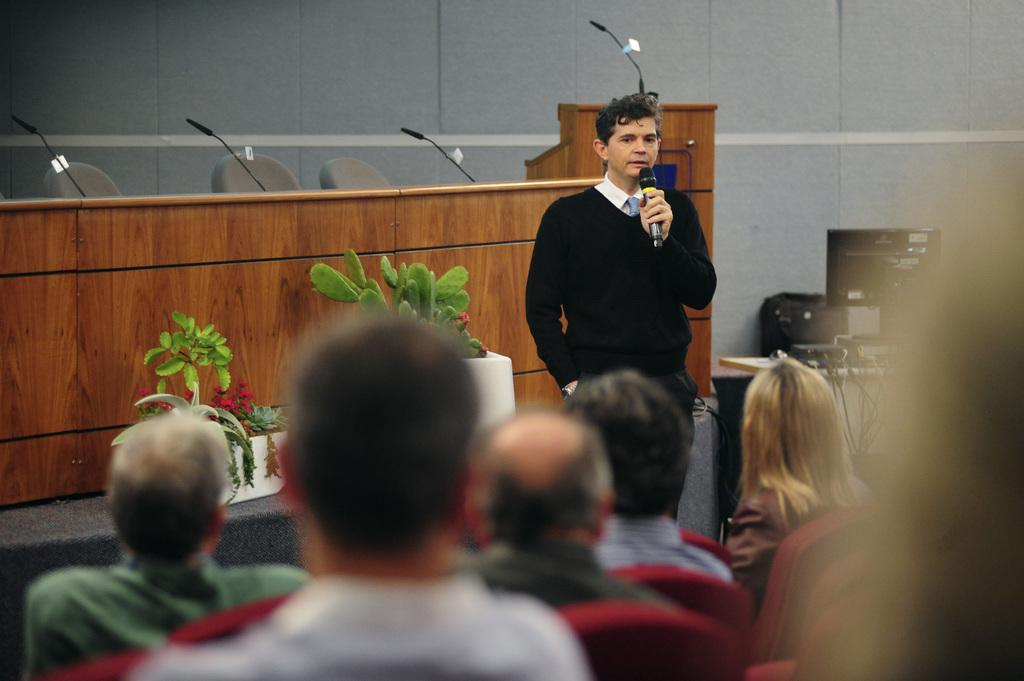What is the primary subject in the image? There is a person standing in the image. What can be seen in the background of the image? There is a wooden table in the background of the image. What type of vegetation is visible behind the person? There are plants behind the person. Are there any other people visible in the image? Yes, there are people visible at the bottom of the image. What type of gate is visible in the image? There is no gate present in the image. What type of suit is the person wearing in the image? The provided facts do not mention the person's clothing, so we cannot determine if they are wearing a suit or any other specific type of clothing. 